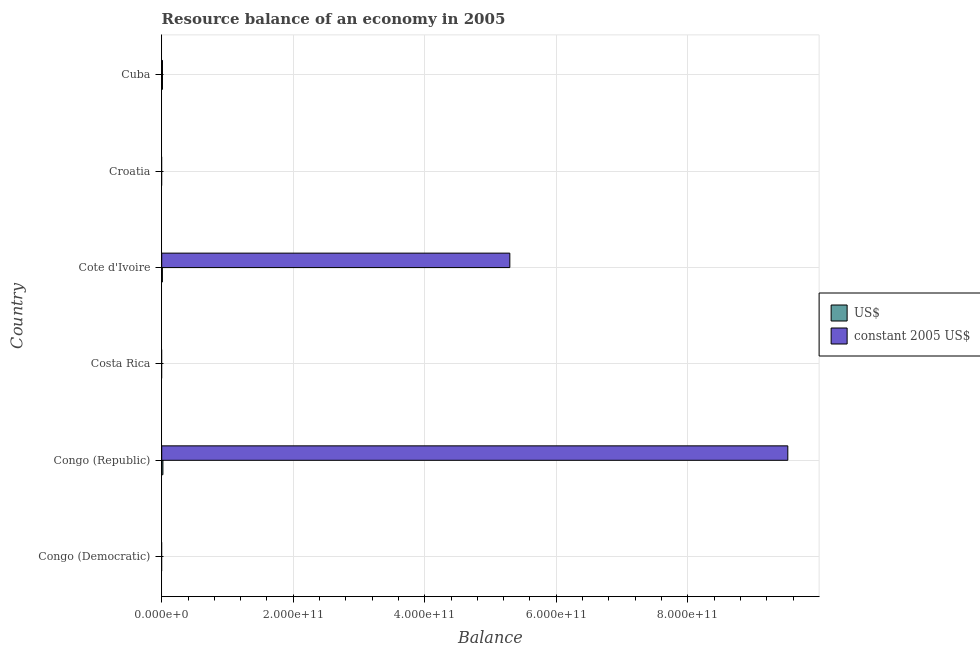How many bars are there on the 3rd tick from the bottom?
Keep it short and to the point. 0. What is the label of the 3rd group of bars from the top?
Provide a short and direct response. Cote d'Ivoire. Across all countries, what is the maximum resource balance in constant us$?
Keep it short and to the point. 9.52e+11. In which country was the resource balance in us$ maximum?
Keep it short and to the point. Congo (Republic). What is the total resource balance in constant us$ in the graph?
Offer a terse response. 1.48e+12. What is the difference between the resource balance in constant us$ in Congo (Republic) and that in Cote d'Ivoire?
Offer a terse response. 4.23e+11. What is the difference between the resource balance in constant us$ in Cote d'Ivoire and the resource balance in us$ in Congo (Republic)?
Your response must be concise. 5.28e+11. What is the average resource balance in constant us$ per country?
Offer a terse response. 2.47e+11. What is the difference between the resource balance in us$ and resource balance in constant us$ in Cote d'Ivoire?
Keep it short and to the point. -5.28e+11. In how many countries, is the resource balance in constant us$ greater than 400000000000 units?
Offer a very short reply. 2. Is the resource balance in constant us$ in Cote d'Ivoire less than that in Cuba?
Offer a terse response. No. Is the difference between the resource balance in constant us$ in Congo (Republic) and Cuba greater than the difference between the resource balance in us$ in Congo (Republic) and Cuba?
Keep it short and to the point. Yes. What is the difference between the highest and the second highest resource balance in us$?
Keep it short and to the point. 6.65e+08. What is the difference between the highest and the lowest resource balance in constant us$?
Give a very brief answer. 9.52e+11. In how many countries, is the resource balance in constant us$ greater than the average resource balance in constant us$ taken over all countries?
Ensure brevity in your answer.  2. Is the sum of the resource balance in constant us$ in Cote d'Ivoire and Cuba greater than the maximum resource balance in us$ across all countries?
Give a very brief answer. Yes. Are all the bars in the graph horizontal?
Your response must be concise. Yes. How many countries are there in the graph?
Offer a terse response. 6. What is the difference between two consecutive major ticks on the X-axis?
Your response must be concise. 2.00e+11. Does the graph contain any zero values?
Provide a succinct answer. Yes. Where does the legend appear in the graph?
Offer a terse response. Center right. How are the legend labels stacked?
Provide a short and direct response. Vertical. What is the title of the graph?
Ensure brevity in your answer.  Resource balance of an economy in 2005. What is the label or title of the X-axis?
Your response must be concise. Balance. What is the label or title of the Y-axis?
Provide a succinct answer. Country. What is the Balance in constant 2005 US$ in Congo (Democratic)?
Offer a very short reply. 0. What is the Balance of US$ in Congo (Republic)?
Offer a terse response. 1.80e+09. What is the Balance of constant 2005 US$ in Congo (Republic)?
Your answer should be compact. 9.52e+11. What is the Balance in constant 2005 US$ in Costa Rica?
Provide a succinct answer. 0. What is the Balance of US$ in Cote d'Ivoire?
Your answer should be compact. 1.00e+09. What is the Balance of constant 2005 US$ in Cote d'Ivoire?
Your answer should be very brief. 5.29e+11. What is the Balance in constant 2005 US$ in Croatia?
Keep it short and to the point. 0. What is the Balance in US$ in Cuba?
Offer a terse response. 1.14e+09. What is the Balance of constant 2005 US$ in Cuba?
Provide a succinct answer. 1.14e+09. Across all countries, what is the maximum Balance in US$?
Your answer should be very brief. 1.80e+09. Across all countries, what is the maximum Balance of constant 2005 US$?
Keep it short and to the point. 9.52e+11. Across all countries, what is the minimum Balance of constant 2005 US$?
Provide a short and direct response. 0. What is the total Balance of US$ in the graph?
Make the answer very short. 3.95e+09. What is the total Balance of constant 2005 US$ in the graph?
Your answer should be very brief. 1.48e+12. What is the difference between the Balance in US$ in Congo (Republic) and that in Cote d'Ivoire?
Provide a short and direct response. 8.01e+08. What is the difference between the Balance of constant 2005 US$ in Congo (Republic) and that in Cote d'Ivoire?
Provide a short and direct response. 4.23e+11. What is the difference between the Balance in US$ in Congo (Republic) and that in Cuba?
Offer a very short reply. 6.65e+08. What is the difference between the Balance of constant 2005 US$ in Congo (Republic) and that in Cuba?
Your response must be concise. 9.51e+11. What is the difference between the Balance of US$ in Cote d'Ivoire and that in Cuba?
Ensure brevity in your answer.  -1.37e+08. What is the difference between the Balance of constant 2005 US$ in Cote d'Ivoire and that in Cuba?
Keep it short and to the point. 5.28e+11. What is the difference between the Balance in US$ in Congo (Republic) and the Balance in constant 2005 US$ in Cote d'Ivoire?
Your answer should be compact. -5.28e+11. What is the difference between the Balance in US$ in Congo (Republic) and the Balance in constant 2005 US$ in Cuba?
Ensure brevity in your answer.  6.65e+08. What is the difference between the Balance of US$ in Cote d'Ivoire and the Balance of constant 2005 US$ in Cuba?
Your response must be concise. -1.37e+08. What is the average Balance in US$ per country?
Ensure brevity in your answer.  6.58e+08. What is the average Balance in constant 2005 US$ per country?
Give a very brief answer. 2.47e+11. What is the difference between the Balance in US$ and Balance in constant 2005 US$ in Congo (Republic)?
Provide a succinct answer. -9.50e+11. What is the difference between the Balance in US$ and Balance in constant 2005 US$ in Cote d'Ivoire?
Make the answer very short. -5.28e+11. What is the difference between the Balance of US$ and Balance of constant 2005 US$ in Cuba?
Offer a very short reply. 0. What is the ratio of the Balance of US$ in Congo (Republic) to that in Cote d'Ivoire?
Make the answer very short. 1.8. What is the ratio of the Balance in constant 2005 US$ in Congo (Republic) to that in Cote d'Ivoire?
Your response must be concise. 1.8. What is the ratio of the Balance in US$ in Congo (Republic) to that in Cuba?
Ensure brevity in your answer.  1.58. What is the ratio of the Balance of constant 2005 US$ in Congo (Republic) to that in Cuba?
Give a very brief answer. 834.92. What is the ratio of the Balance in US$ in Cote d'Ivoire to that in Cuba?
Your answer should be very brief. 0.88. What is the ratio of the Balance in constant 2005 US$ in Cote d'Ivoire to that in Cuba?
Provide a succinct answer. 464.23. What is the difference between the highest and the second highest Balance of US$?
Offer a very short reply. 6.65e+08. What is the difference between the highest and the second highest Balance of constant 2005 US$?
Offer a very short reply. 4.23e+11. What is the difference between the highest and the lowest Balance in US$?
Your answer should be very brief. 1.80e+09. What is the difference between the highest and the lowest Balance of constant 2005 US$?
Provide a succinct answer. 9.52e+11. 